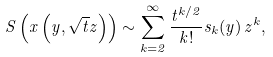<formula> <loc_0><loc_0><loc_500><loc_500>S \left ( x \left ( y , \sqrt { t } z \right ) \right ) \sim \sum _ { k = 2 } ^ { \infty } \frac { t ^ { k / 2 } } { k ! } s _ { k } ( y ) \, z ^ { k } ,</formula> 